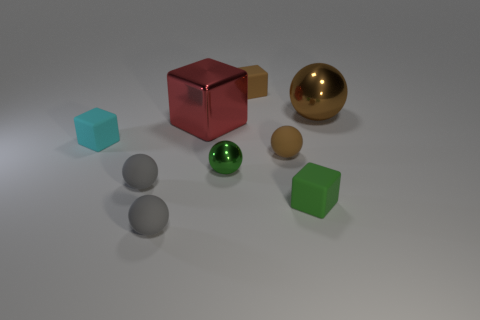What material is the other object that is the same color as the tiny metal thing?
Your answer should be compact. Rubber. There is a matte block behind the large red metal cube; is it the same color as the large shiny sphere?
Provide a short and direct response. Yes. How many other objects are the same color as the large ball?
Your answer should be very brief. 2. There is a large brown object that is made of the same material as the red object; what shape is it?
Keep it short and to the point. Sphere. Is the color of the metallic object that is to the right of the brown matte cube the same as the small matte sphere that is behind the tiny green metal sphere?
Your answer should be very brief. Yes. Does the brown sphere to the right of the brown matte sphere have the same material as the green ball?
Make the answer very short. Yes. Are there any other balls of the same color as the big metallic ball?
Your answer should be compact. Yes. Does the cyan object in front of the brown metal object have the same shape as the tiny green object that is right of the tiny green metal ball?
Your answer should be compact. Yes. Is there a green thing made of the same material as the big block?
Give a very brief answer. Yes. What number of gray things are big shiny spheres or small matte spheres?
Your response must be concise. 2. 